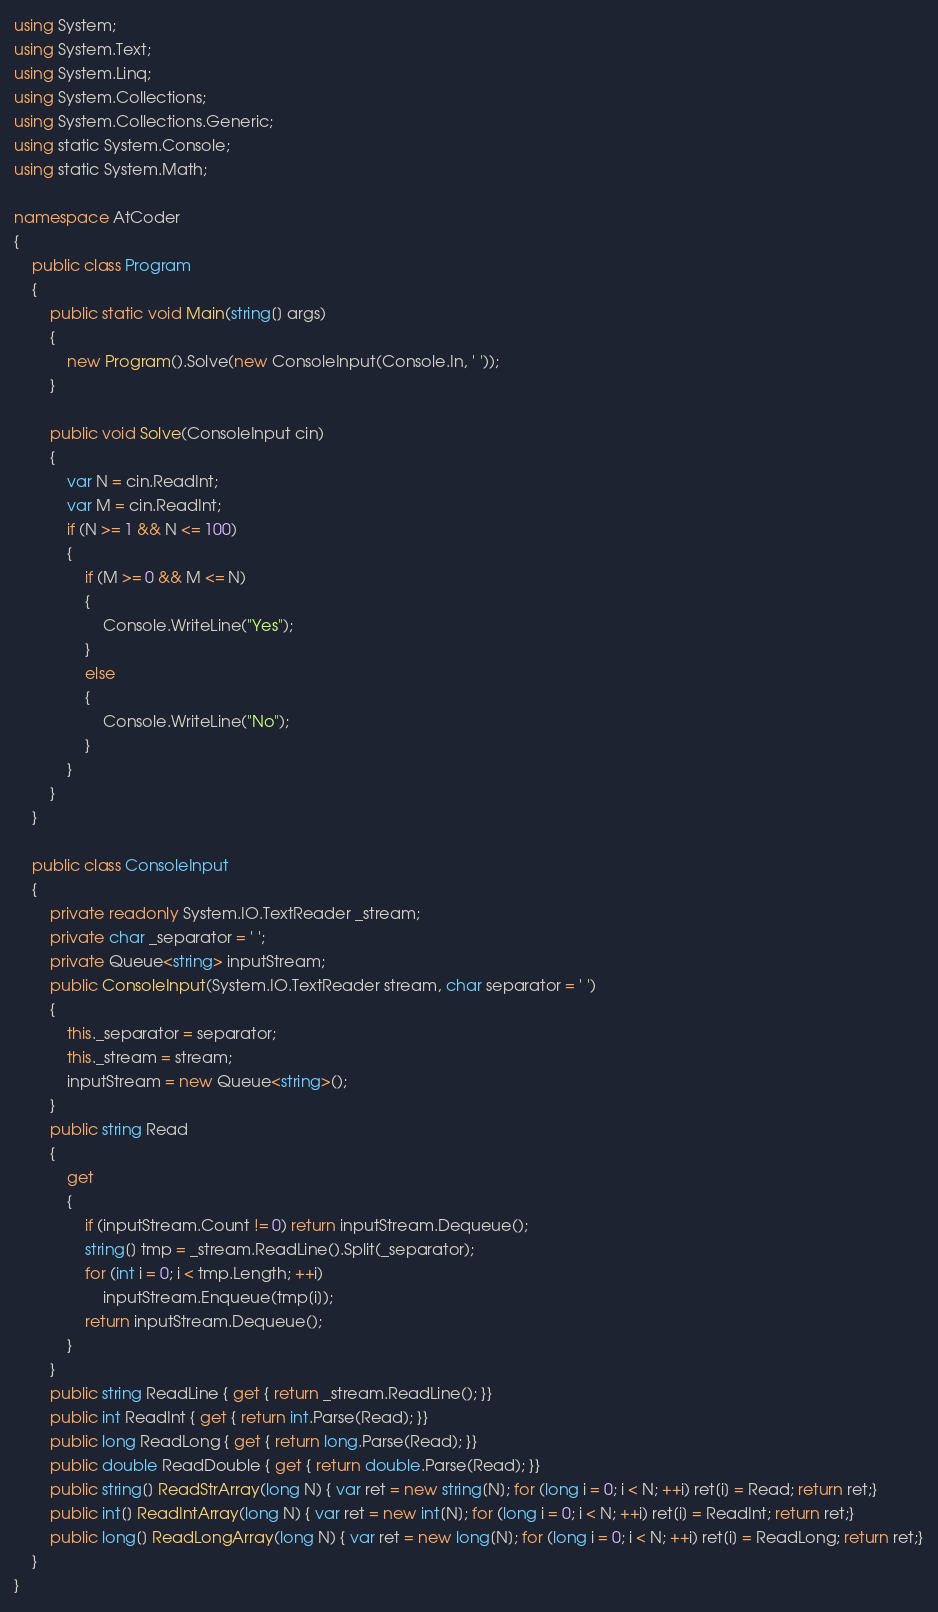<code> <loc_0><loc_0><loc_500><loc_500><_C#_>using System;
using System.Text;
using System.Linq;
using System.Collections;
using System.Collections.Generic;
using static System.Console;
using static System.Math;

namespace AtCoder
{
    public class Program
    {
        public static void Main(string[] args)
        {
            new Program().Solve(new ConsoleInput(Console.In, ' '));
        }

        public void Solve(ConsoleInput cin)
        {
            var N = cin.ReadInt;
            var M = cin.ReadInt;
            if (N >= 1 && N <= 100)
            {
                if (M >= 0 && M <= N)
                {
                    Console.WriteLine("Yes");
                }
                else
                {
                    Console.WriteLine("No");
                }
            }
        }
    }

    public class ConsoleInput
    {
        private readonly System.IO.TextReader _stream;
        private char _separator = ' ';
        private Queue<string> inputStream;
        public ConsoleInput(System.IO.TextReader stream, char separator = ' ')
        {
            this._separator = separator;
            this._stream = stream;
            inputStream = new Queue<string>();
        }
        public string Read
        {
            get
            {
                if (inputStream.Count != 0) return inputStream.Dequeue();
                string[] tmp = _stream.ReadLine().Split(_separator);
                for (int i = 0; i < tmp.Length; ++i)
                    inputStream.Enqueue(tmp[i]);
                return inputStream.Dequeue();
            }
        }
        public string ReadLine { get { return _stream.ReadLine(); }}
        public int ReadInt { get { return int.Parse(Read); }}
        public long ReadLong { get { return long.Parse(Read); }}
        public double ReadDouble { get { return double.Parse(Read); }}
        public string[] ReadStrArray(long N) { var ret = new string[N]; for (long i = 0; i < N; ++i) ret[i] = Read; return ret;}
        public int[] ReadIntArray(long N) { var ret = new int[N]; for (long i = 0; i < N; ++i) ret[i] = ReadInt; return ret;}
        public long[] ReadLongArray(long N) { var ret = new long[N]; for (long i = 0; i < N; ++i) ret[i] = ReadLong; return ret;}
    }
}</code> 